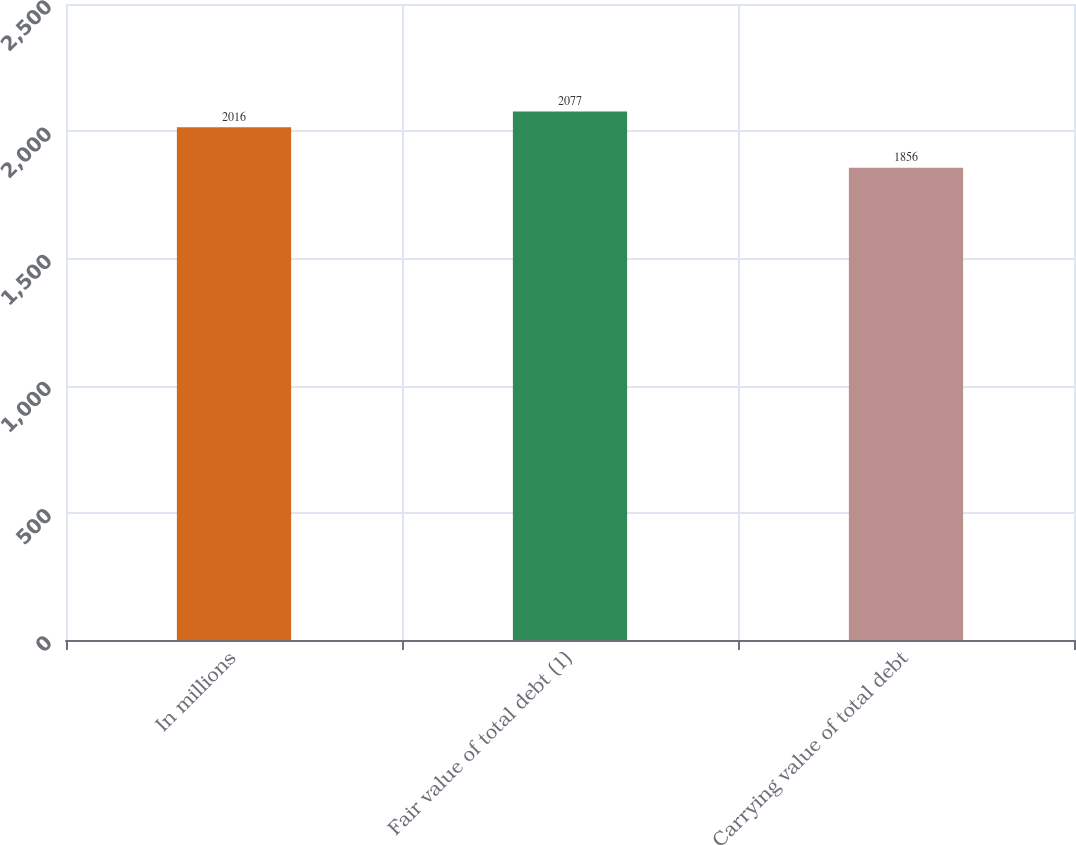<chart> <loc_0><loc_0><loc_500><loc_500><bar_chart><fcel>In millions<fcel>Fair value of total debt (1)<fcel>Carrying value of total debt<nl><fcel>2016<fcel>2077<fcel>1856<nl></chart> 